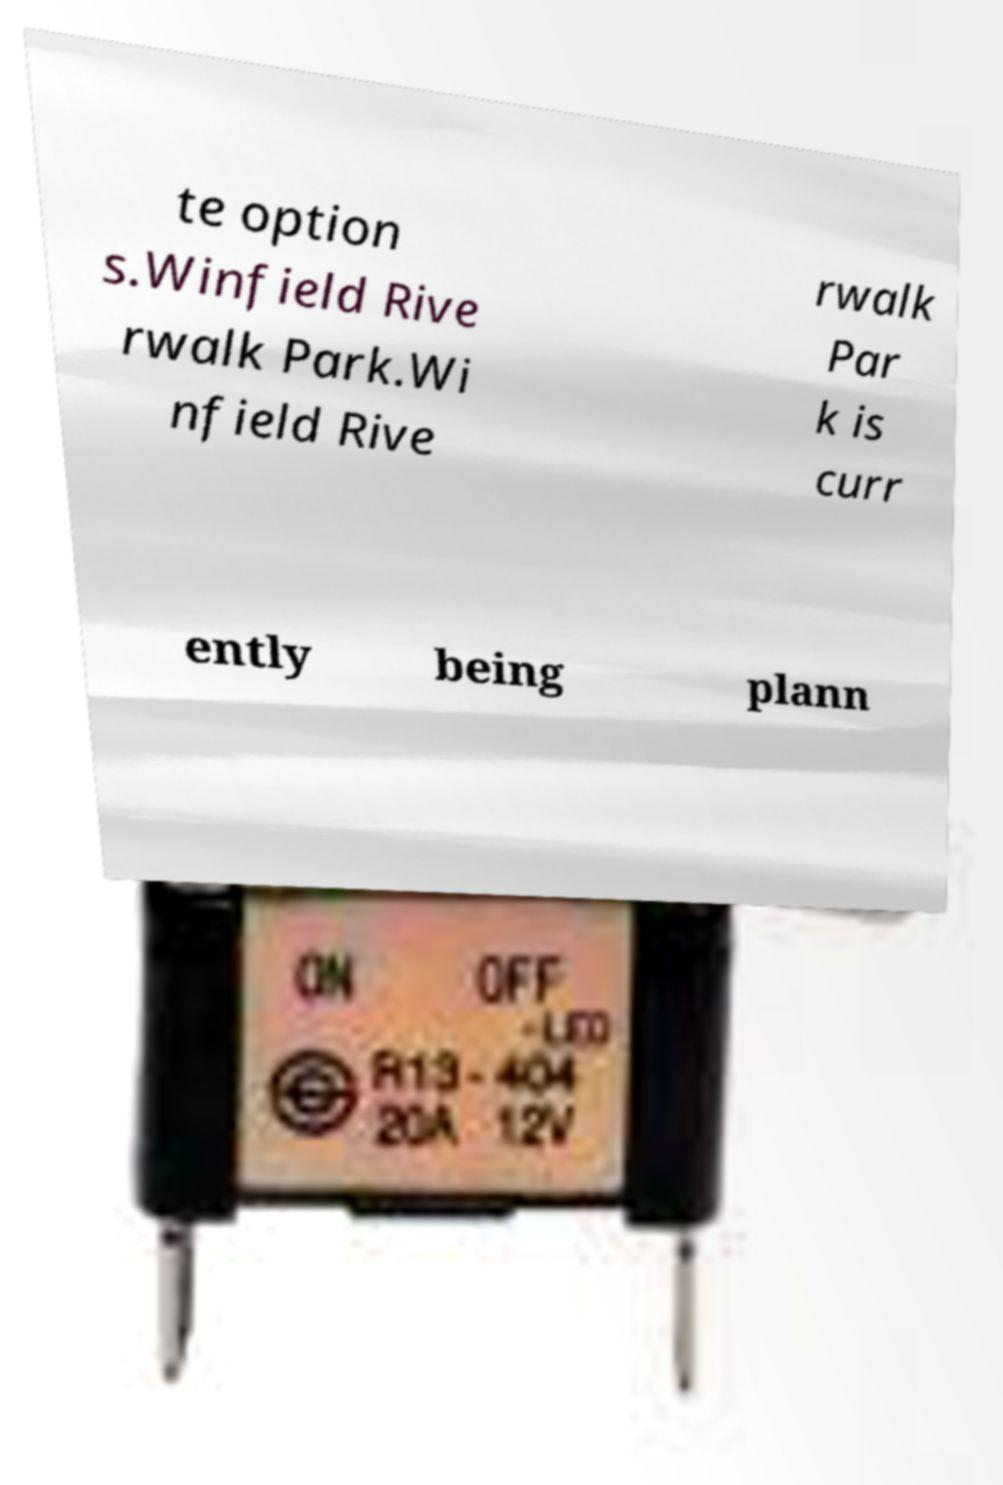Can you read and provide the text displayed in the image?This photo seems to have some interesting text. Can you extract and type it out for me? te option s.Winfield Rive rwalk Park.Wi nfield Rive rwalk Par k is curr ently being plann 